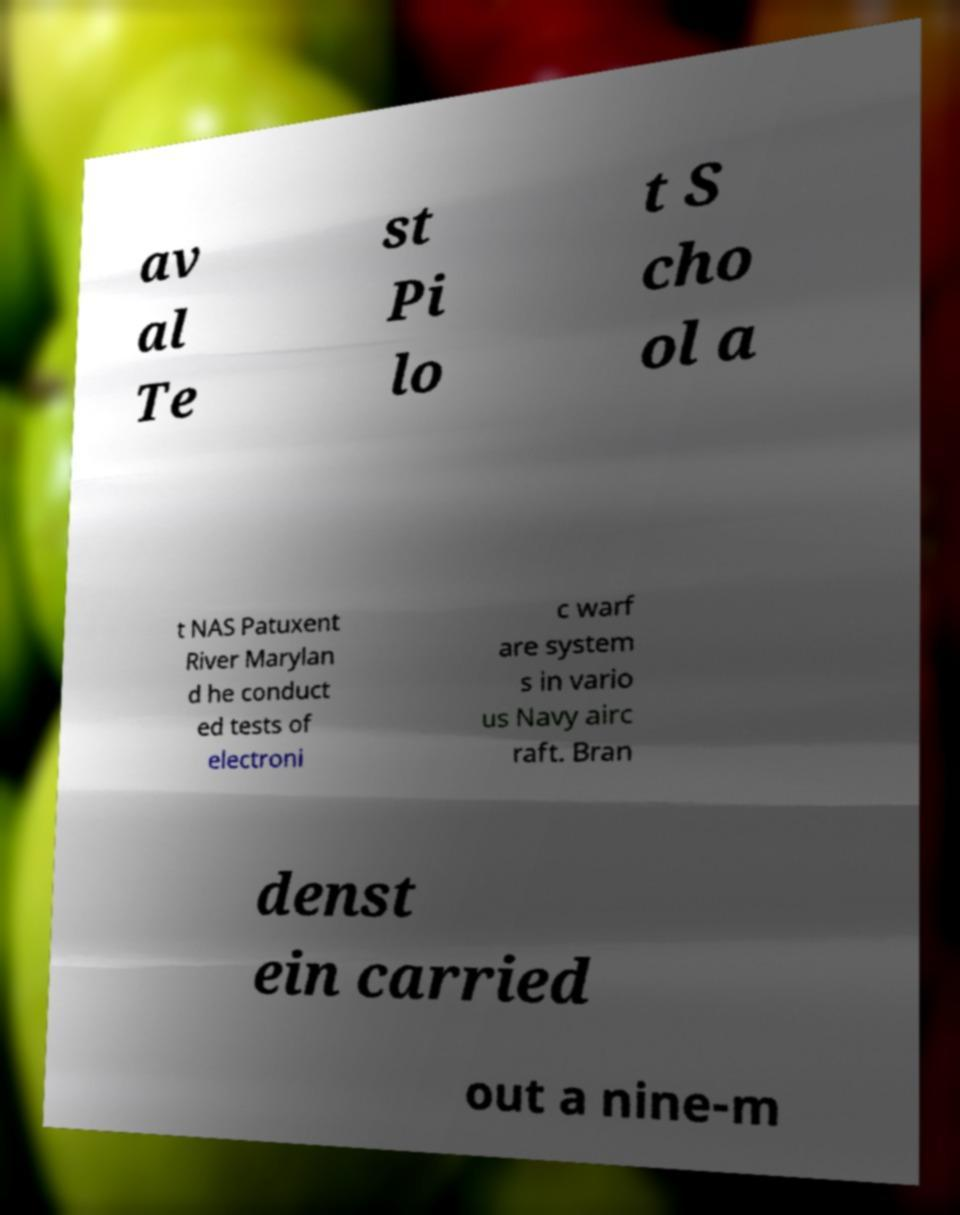What messages or text are displayed in this image? I need them in a readable, typed format. av al Te st Pi lo t S cho ol a t NAS Patuxent River Marylan d he conduct ed tests of electroni c warf are system s in vario us Navy airc raft. Bran denst ein carried out a nine-m 